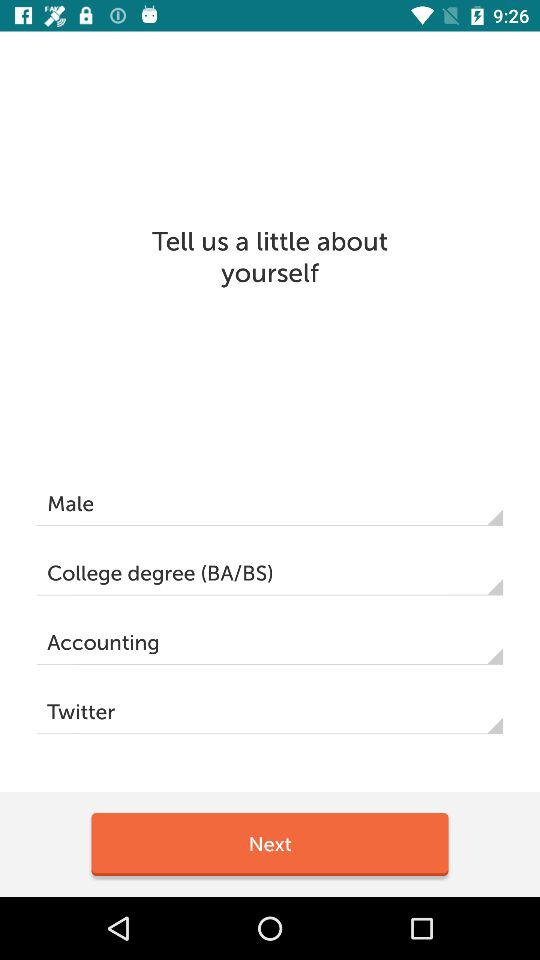How many text inputs are there for the user to fill in?
Answer the question using a single word or phrase. 4 